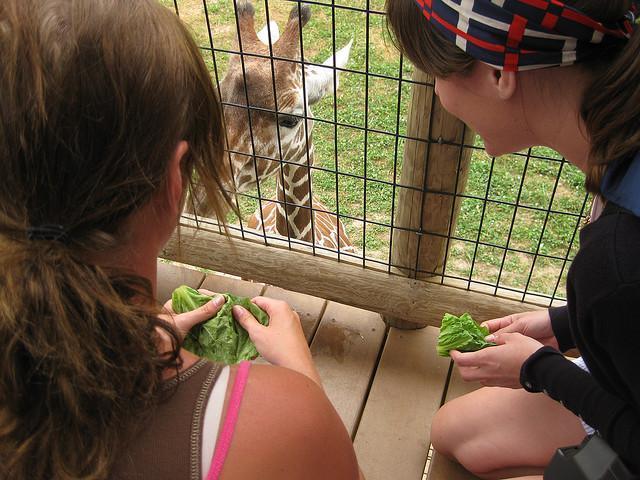How many people can you see?
Give a very brief answer. 2. How many human statues are to the left of the clock face?
Give a very brief answer. 0. 